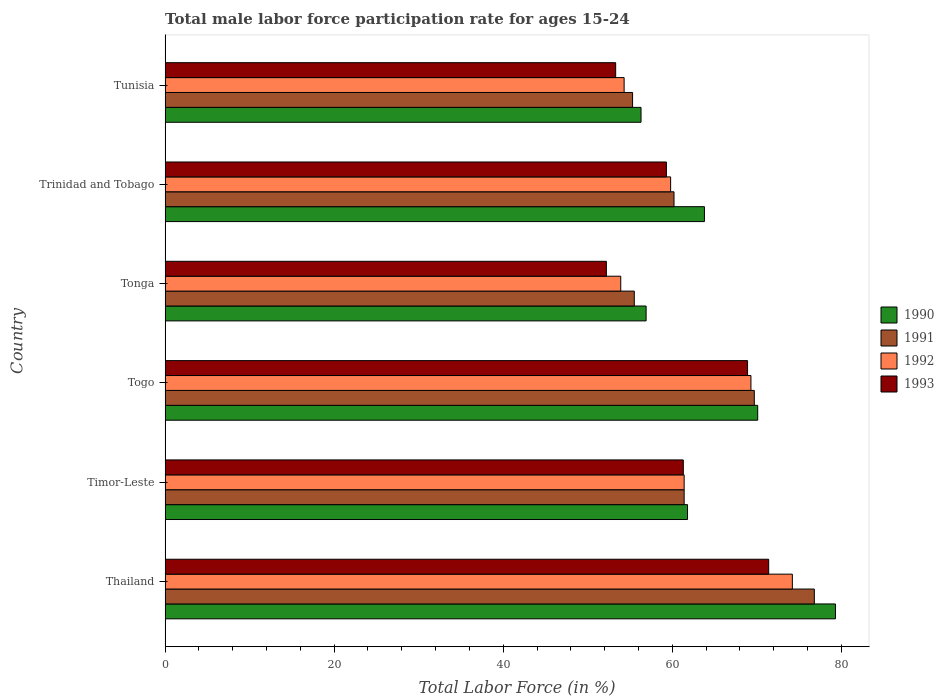Are the number of bars on each tick of the Y-axis equal?
Your answer should be compact. Yes. How many bars are there on the 1st tick from the bottom?
Your response must be concise. 4. What is the label of the 3rd group of bars from the top?
Keep it short and to the point. Tonga. In how many cases, is the number of bars for a given country not equal to the number of legend labels?
Make the answer very short. 0. What is the male labor force participation rate in 1993 in Trinidad and Tobago?
Your answer should be compact. 59.3. Across all countries, what is the maximum male labor force participation rate in 1993?
Your answer should be very brief. 71.4. Across all countries, what is the minimum male labor force participation rate in 1991?
Offer a terse response. 55.3. In which country was the male labor force participation rate in 1993 maximum?
Your answer should be compact. Thailand. In which country was the male labor force participation rate in 1991 minimum?
Offer a terse response. Tunisia. What is the total male labor force participation rate in 1992 in the graph?
Offer a terse response. 372.9. What is the difference between the male labor force participation rate in 1990 in Togo and that in Tonga?
Offer a very short reply. 13.2. What is the average male labor force participation rate in 1992 per country?
Offer a terse response. 62.15. In how many countries, is the male labor force participation rate in 1990 greater than 72 %?
Provide a short and direct response. 1. What is the ratio of the male labor force participation rate in 1991 in Thailand to that in Tonga?
Your response must be concise. 1.38. Is the male labor force participation rate in 1990 in Tonga less than that in Trinidad and Tobago?
Your answer should be compact. Yes. What is the difference between the highest and the second highest male labor force participation rate in 1991?
Provide a succinct answer. 7.1. What is the difference between the highest and the lowest male labor force participation rate in 1993?
Give a very brief answer. 19.2. In how many countries, is the male labor force participation rate in 1993 greater than the average male labor force participation rate in 1993 taken over all countries?
Provide a succinct answer. 3. Is it the case that in every country, the sum of the male labor force participation rate in 1991 and male labor force participation rate in 1990 is greater than the male labor force participation rate in 1992?
Give a very brief answer. Yes. Are all the bars in the graph horizontal?
Make the answer very short. Yes. How many countries are there in the graph?
Keep it short and to the point. 6. What is the difference between two consecutive major ticks on the X-axis?
Your answer should be compact. 20. Does the graph contain any zero values?
Your answer should be compact. No. Does the graph contain grids?
Keep it short and to the point. No. How many legend labels are there?
Your answer should be very brief. 4. What is the title of the graph?
Provide a succinct answer. Total male labor force participation rate for ages 15-24. What is the label or title of the X-axis?
Offer a terse response. Total Labor Force (in %). What is the label or title of the Y-axis?
Give a very brief answer. Country. What is the Total Labor Force (in %) of 1990 in Thailand?
Your answer should be very brief. 79.3. What is the Total Labor Force (in %) of 1991 in Thailand?
Offer a terse response. 76.8. What is the Total Labor Force (in %) of 1992 in Thailand?
Your answer should be very brief. 74.2. What is the Total Labor Force (in %) of 1993 in Thailand?
Offer a very short reply. 71.4. What is the Total Labor Force (in %) in 1990 in Timor-Leste?
Ensure brevity in your answer.  61.8. What is the Total Labor Force (in %) in 1991 in Timor-Leste?
Offer a very short reply. 61.4. What is the Total Labor Force (in %) in 1992 in Timor-Leste?
Your response must be concise. 61.4. What is the Total Labor Force (in %) in 1993 in Timor-Leste?
Keep it short and to the point. 61.3. What is the Total Labor Force (in %) of 1990 in Togo?
Keep it short and to the point. 70.1. What is the Total Labor Force (in %) in 1991 in Togo?
Offer a terse response. 69.7. What is the Total Labor Force (in %) of 1992 in Togo?
Keep it short and to the point. 69.3. What is the Total Labor Force (in %) of 1993 in Togo?
Make the answer very short. 68.9. What is the Total Labor Force (in %) of 1990 in Tonga?
Offer a terse response. 56.9. What is the Total Labor Force (in %) of 1991 in Tonga?
Provide a succinct answer. 55.5. What is the Total Labor Force (in %) of 1992 in Tonga?
Make the answer very short. 53.9. What is the Total Labor Force (in %) in 1993 in Tonga?
Provide a succinct answer. 52.2. What is the Total Labor Force (in %) of 1990 in Trinidad and Tobago?
Give a very brief answer. 63.8. What is the Total Labor Force (in %) of 1991 in Trinidad and Tobago?
Provide a succinct answer. 60.2. What is the Total Labor Force (in %) of 1992 in Trinidad and Tobago?
Your answer should be compact. 59.8. What is the Total Labor Force (in %) in 1993 in Trinidad and Tobago?
Keep it short and to the point. 59.3. What is the Total Labor Force (in %) in 1990 in Tunisia?
Offer a very short reply. 56.3. What is the Total Labor Force (in %) in 1991 in Tunisia?
Provide a succinct answer. 55.3. What is the Total Labor Force (in %) of 1992 in Tunisia?
Offer a terse response. 54.3. What is the Total Labor Force (in %) of 1993 in Tunisia?
Your answer should be very brief. 53.3. Across all countries, what is the maximum Total Labor Force (in %) of 1990?
Your response must be concise. 79.3. Across all countries, what is the maximum Total Labor Force (in %) of 1991?
Provide a short and direct response. 76.8. Across all countries, what is the maximum Total Labor Force (in %) in 1992?
Provide a succinct answer. 74.2. Across all countries, what is the maximum Total Labor Force (in %) of 1993?
Give a very brief answer. 71.4. Across all countries, what is the minimum Total Labor Force (in %) in 1990?
Ensure brevity in your answer.  56.3. Across all countries, what is the minimum Total Labor Force (in %) of 1991?
Make the answer very short. 55.3. Across all countries, what is the minimum Total Labor Force (in %) of 1992?
Your response must be concise. 53.9. Across all countries, what is the minimum Total Labor Force (in %) of 1993?
Provide a short and direct response. 52.2. What is the total Total Labor Force (in %) in 1990 in the graph?
Ensure brevity in your answer.  388.2. What is the total Total Labor Force (in %) of 1991 in the graph?
Keep it short and to the point. 378.9. What is the total Total Labor Force (in %) of 1992 in the graph?
Offer a terse response. 372.9. What is the total Total Labor Force (in %) of 1993 in the graph?
Your response must be concise. 366.4. What is the difference between the Total Labor Force (in %) in 1991 in Thailand and that in Timor-Leste?
Your answer should be very brief. 15.4. What is the difference between the Total Labor Force (in %) of 1990 in Thailand and that in Togo?
Your answer should be very brief. 9.2. What is the difference between the Total Labor Force (in %) in 1992 in Thailand and that in Togo?
Offer a terse response. 4.9. What is the difference between the Total Labor Force (in %) of 1990 in Thailand and that in Tonga?
Your answer should be compact. 22.4. What is the difference between the Total Labor Force (in %) in 1991 in Thailand and that in Tonga?
Your answer should be compact. 21.3. What is the difference between the Total Labor Force (in %) of 1992 in Thailand and that in Tonga?
Provide a succinct answer. 20.3. What is the difference between the Total Labor Force (in %) of 1993 in Thailand and that in Tonga?
Keep it short and to the point. 19.2. What is the difference between the Total Labor Force (in %) of 1990 in Thailand and that in Trinidad and Tobago?
Provide a short and direct response. 15.5. What is the difference between the Total Labor Force (in %) in 1992 in Thailand and that in Trinidad and Tobago?
Your answer should be compact. 14.4. What is the difference between the Total Labor Force (in %) of 1993 in Thailand and that in Trinidad and Tobago?
Give a very brief answer. 12.1. What is the difference between the Total Labor Force (in %) in 1991 in Thailand and that in Tunisia?
Your response must be concise. 21.5. What is the difference between the Total Labor Force (in %) of 1991 in Timor-Leste and that in Togo?
Your answer should be compact. -8.3. What is the difference between the Total Labor Force (in %) of 1992 in Timor-Leste and that in Togo?
Offer a very short reply. -7.9. What is the difference between the Total Labor Force (in %) of 1990 in Timor-Leste and that in Tonga?
Provide a succinct answer. 4.9. What is the difference between the Total Labor Force (in %) in 1991 in Timor-Leste and that in Tonga?
Give a very brief answer. 5.9. What is the difference between the Total Labor Force (in %) of 1992 in Timor-Leste and that in Tonga?
Make the answer very short. 7.5. What is the difference between the Total Labor Force (in %) of 1990 in Timor-Leste and that in Trinidad and Tobago?
Provide a short and direct response. -2. What is the difference between the Total Labor Force (in %) in 1991 in Timor-Leste and that in Trinidad and Tobago?
Provide a short and direct response. 1.2. What is the difference between the Total Labor Force (in %) of 1992 in Timor-Leste and that in Trinidad and Tobago?
Make the answer very short. 1.6. What is the difference between the Total Labor Force (in %) in 1993 in Timor-Leste and that in Tunisia?
Offer a terse response. 8. What is the difference between the Total Labor Force (in %) of 1990 in Togo and that in Tonga?
Ensure brevity in your answer.  13.2. What is the difference between the Total Labor Force (in %) in 1992 in Togo and that in Tonga?
Keep it short and to the point. 15.4. What is the difference between the Total Labor Force (in %) of 1993 in Togo and that in Tonga?
Provide a short and direct response. 16.7. What is the difference between the Total Labor Force (in %) of 1991 in Togo and that in Trinidad and Tobago?
Offer a terse response. 9.5. What is the difference between the Total Labor Force (in %) of 1993 in Togo and that in Trinidad and Tobago?
Give a very brief answer. 9.6. What is the difference between the Total Labor Force (in %) in 1990 in Togo and that in Tunisia?
Provide a short and direct response. 13.8. What is the difference between the Total Labor Force (in %) in 1992 in Togo and that in Tunisia?
Provide a succinct answer. 15. What is the difference between the Total Labor Force (in %) in 1993 in Togo and that in Tunisia?
Your answer should be very brief. 15.6. What is the difference between the Total Labor Force (in %) in 1990 in Tonga and that in Trinidad and Tobago?
Offer a very short reply. -6.9. What is the difference between the Total Labor Force (in %) of 1993 in Tonga and that in Trinidad and Tobago?
Provide a short and direct response. -7.1. What is the difference between the Total Labor Force (in %) in 1991 in Tonga and that in Tunisia?
Ensure brevity in your answer.  0.2. What is the difference between the Total Labor Force (in %) in 1993 in Tonga and that in Tunisia?
Give a very brief answer. -1.1. What is the difference between the Total Labor Force (in %) in 1991 in Trinidad and Tobago and that in Tunisia?
Give a very brief answer. 4.9. What is the difference between the Total Labor Force (in %) in 1992 in Trinidad and Tobago and that in Tunisia?
Provide a succinct answer. 5.5. What is the difference between the Total Labor Force (in %) in 1993 in Trinidad and Tobago and that in Tunisia?
Offer a very short reply. 6. What is the difference between the Total Labor Force (in %) of 1990 in Thailand and the Total Labor Force (in %) of 1991 in Timor-Leste?
Your answer should be compact. 17.9. What is the difference between the Total Labor Force (in %) of 1990 in Thailand and the Total Labor Force (in %) of 1992 in Timor-Leste?
Offer a terse response. 17.9. What is the difference between the Total Labor Force (in %) in 1990 in Thailand and the Total Labor Force (in %) in 1993 in Timor-Leste?
Give a very brief answer. 18. What is the difference between the Total Labor Force (in %) in 1991 in Thailand and the Total Labor Force (in %) in 1992 in Timor-Leste?
Provide a short and direct response. 15.4. What is the difference between the Total Labor Force (in %) of 1991 in Thailand and the Total Labor Force (in %) of 1993 in Timor-Leste?
Offer a very short reply. 15.5. What is the difference between the Total Labor Force (in %) in 1992 in Thailand and the Total Labor Force (in %) in 1993 in Timor-Leste?
Offer a very short reply. 12.9. What is the difference between the Total Labor Force (in %) of 1990 in Thailand and the Total Labor Force (in %) of 1991 in Togo?
Your answer should be compact. 9.6. What is the difference between the Total Labor Force (in %) of 1990 in Thailand and the Total Labor Force (in %) of 1993 in Togo?
Provide a succinct answer. 10.4. What is the difference between the Total Labor Force (in %) of 1990 in Thailand and the Total Labor Force (in %) of 1991 in Tonga?
Offer a terse response. 23.8. What is the difference between the Total Labor Force (in %) of 1990 in Thailand and the Total Labor Force (in %) of 1992 in Tonga?
Your answer should be compact. 25.4. What is the difference between the Total Labor Force (in %) in 1990 in Thailand and the Total Labor Force (in %) in 1993 in Tonga?
Your answer should be compact. 27.1. What is the difference between the Total Labor Force (in %) of 1991 in Thailand and the Total Labor Force (in %) of 1992 in Tonga?
Offer a very short reply. 22.9. What is the difference between the Total Labor Force (in %) in 1991 in Thailand and the Total Labor Force (in %) in 1993 in Tonga?
Your answer should be compact. 24.6. What is the difference between the Total Labor Force (in %) in 1992 in Thailand and the Total Labor Force (in %) in 1993 in Tonga?
Offer a very short reply. 22. What is the difference between the Total Labor Force (in %) of 1990 in Thailand and the Total Labor Force (in %) of 1993 in Trinidad and Tobago?
Offer a very short reply. 20. What is the difference between the Total Labor Force (in %) in 1991 in Thailand and the Total Labor Force (in %) in 1992 in Trinidad and Tobago?
Keep it short and to the point. 17. What is the difference between the Total Labor Force (in %) of 1991 in Thailand and the Total Labor Force (in %) of 1993 in Trinidad and Tobago?
Offer a terse response. 17.5. What is the difference between the Total Labor Force (in %) of 1990 in Thailand and the Total Labor Force (in %) of 1992 in Tunisia?
Provide a succinct answer. 25. What is the difference between the Total Labor Force (in %) in 1992 in Thailand and the Total Labor Force (in %) in 1993 in Tunisia?
Make the answer very short. 20.9. What is the difference between the Total Labor Force (in %) of 1990 in Timor-Leste and the Total Labor Force (in %) of 1991 in Togo?
Give a very brief answer. -7.9. What is the difference between the Total Labor Force (in %) of 1990 in Timor-Leste and the Total Labor Force (in %) of 1992 in Togo?
Offer a very short reply. -7.5. What is the difference between the Total Labor Force (in %) of 1990 in Timor-Leste and the Total Labor Force (in %) of 1993 in Togo?
Ensure brevity in your answer.  -7.1. What is the difference between the Total Labor Force (in %) in 1991 in Timor-Leste and the Total Labor Force (in %) in 1992 in Togo?
Provide a short and direct response. -7.9. What is the difference between the Total Labor Force (in %) in 1991 in Timor-Leste and the Total Labor Force (in %) in 1993 in Togo?
Offer a terse response. -7.5. What is the difference between the Total Labor Force (in %) of 1992 in Timor-Leste and the Total Labor Force (in %) of 1993 in Togo?
Your answer should be very brief. -7.5. What is the difference between the Total Labor Force (in %) of 1990 in Timor-Leste and the Total Labor Force (in %) of 1991 in Tonga?
Your answer should be very brief. 6.3. What is the difference between the Total Labor Force (in %) of 1990 in Timor-Leste and the Total Labor Force (in %) of 1993 in Tonga?
Ensure brevity in your answer.  9.6. What is the difference between the Total Labor Force (in %) of 1992 in Timor-Leste and the Total Labor Force (in %) of 1993 in Tonga?
Ensure brevity in your answer.  9.2. What is the difference between the Total Labor Force (in %) in 1990 in Timor-Leste and the Total Labor Force (in %) in 1991 in Trinidad and Tobago?
Give a very brief answer. 1.6. What is the difference between the Total Labor Force (in %) of 1990 in Timor-Leste and the Total Labor Force (in %) of 1993 in Trinidad and Tobago?
Provide a short and direct response. 2.5. What is the difference between the Total Labor Force (in %) in 1992 in Timor-Leste and the Total Labor Force (in %) in 1993 in Trinidad and Tobago?
Ensure brevity in your answer.  2.1. What is the difference between the Total Labor Force (in %) in 1991 in Timor-Leste and the Total Labor Force (in %) in 1992 in Tunisia?
Offer a terse response. 7.1. What is the difference between the Total Labor Force (in %) of 1992 in Timor-Leste and the Total Labor Force (in %) of 1993 in Tunisia?
Keep it short and to the point. 8.1. What is the difference between the Total Labor Force (in %) in 1990 in Togo and the Total Labor Force (in %) in 1991 in Tonga?
Ensure brevity in your answer.  14.6. What is the difference between the Total Labor Force (in %) of 1991 in Togo and the Total Labor Force (in %) of 1992 in Tonga?
Your answer should be compact. 15.8. What is the difference between the Total Labor Force (in %) in 1991 in Togo and the Total Labor Force (in %) in 1993 in Tonga?
Keep it short and to the point. 17.5. What is the difference between the Total Labor Force (in %) of 1990 in Togo and the Total Labor Force (in %) of 1991 in Trinidad and Tobago?
Your answer should be compact. 9.9. What is the difference between the Total Labor Force (in %) in 1990 in Togo and the Total Labor Force (in %) in 1993 in Trinidad and Tobago?
Make the answer very short. 10.8. What is the difference between the Total Labor Force (in %) of 1991 in Togo and the Total Labor Force (in %) of 1993 in Trinidad and Tobago?
Offer a terse response. 10.4. What is the difference between the Total Labor Force (in %) of 1992 in Togo and the Total Labor Force (in %) of 1993 in Trinidad and Tobago?
Ensure brevity in your answer.  10. What is the difference between the Total Labor Force (in %) of 1990 in Togo and the Total Labor Force (in %) of 1993 in Tunisia?
Ensure brevity in your answer.  16.8. What is the difference between the Total Labor Force (in %) in 1991 in Togo and the Total Labor Force (in %) in 1992 in Tunisia?
Provide a succinct answer. 15.4. What is the difference between the Total Labor Force (in %) in 1991 in Togo and the Total Labor Force (in %) in 1993 in Tunisia?
Provide a succinct answer. 16.4. What is the difference between the Total Labor Force (in %) in 1992 in Togo and the Total Labor Force (in %) in 1993 in Tunisia?
Offer a very short reply. 16. What is the difference between the Total Labor Force (in %) of 1990 in Tonga and the Total Labor Force (in %) of 1991 in Trinidad and Tobago?
Your answer should be compact. -3.3. What is the difference between the Total Labor Force (in %) in 1990 in Tonga and the Total Labor Force (in %) in 1992 in Trinidad and Tobago?
Your answer should be very brief. -2.9. What is the difference between the Total Labor Force (in %) in 1990 in Tonga and the Total Labor Force (in %) in 1993 in Trinidad and Tobago?
Your response must be concise. -2.4. What is the difference between the Total Labor Force (in %) in 1991 in Tonga and the Total Labor Force (in %) in 1993 in Trinidad and Tobago?
Offer a very short reply. -3.8. What is the difference between the Total Labor Force (in %) in 1990 in Tonga and the Total Labor Force (in %) in 1992 in Tunisia?
Provide a short and direct response. 2.6. What is the difference between the Total Labor Force (in %) in 1990 in Tonga and the Total Labor Force (in %) in 1993 in Tunisia?
Give a very brief answer. 3.6. What is the difference between the Total Labor Force (in %) of 1992 in Tonga and the Total Labor Force (in %) of 1993 in Tunisia?
Your answer should be very brief. 0.6. What is the difference between the Total Labor Force (in %) of 1990 in Trinidad and Tobago and the Total Labor Force (in %) of 1991 in Tunisia?
Offer a very short reply. 8.5. What is the difference between the Total Labor Force (in %) of 1990 in Trinidad and Tobago and the Total Labor Force (in %) of 1992 in Tunisia?
Your response must be concise. 9.5. What is the difference between the Total Labor Force (in %) in 1990 in Trinidad and Tobago and the Total Labor Force (in %) in 1993 in Tunisia?
Give a very brief answer. 10.5. What is the difference between the Total Labor Force (in %) of 1991 in Trinidad and Tobago and the Total Labor Force (in %) of 1992 in Tunisia?
Ensure brevity in your answer.  5.9. What is the difference between the Total Labor Force (in %) of 1991 in Trinidad and Tobago and the Total Labor Force (in %) of 1993 in Tunisia?
Offer a terse response. 6.9. What is the average Total Labor Force (in %) of 1990 per country?
Make the answer very short. 64.7. What is the average Total Labor Force (in %) of 1991 per country?
Provide a short and direct response. 63.15. What is the average Total Labor Force (in %) in 1992 per country?
Give a very brief answer. 62.15. What is the average Total Labor Force (in %) of 1993 per country?
Make the answer very short. 61.07. What is the difference between the Total Labor Force (in %) of 1990 and Total Labor Force (in %) of 1991 in Thailand?
Keep it short and to the point. 2.5. What is the difference between the Total Labor Force (in %) of 1990 and Total Labor Force (in %) of 1992 in Thailand?
Your answer should be very brief. 5.1. What is the difference between the Total Labor Force (in %) in 1990 and Total Labor Force (in %) in 1993 in Thailand?
Make the answer very short. 7.9. What is the difference between the Total Labor Force (in %) in 1992 and Total Labor Force (in %) in 1993 in Thailand?
Ensure brevity in your answer.  2.8. What is the difference between the Total Labor Force (in %) in 1990 and Total Labor Force (in %) in 1991 in Timor-Leste?
Ensure brevity in your answer.  0.4. What is the difference between the Total Labor Force (in %) of 1990 and Total Labor Force (in %) of 1993 in Timor-Leste?
Keep it short and to the point. 0.5. What is the difference between the Total Labor Force (in %) in 1991 and Total Labor Force (in %) in 1993 in Timor-Leste?
Your answer should be very brief. 0.1. What is the difference between the Total Labor Force (in %) in 1992 and Total Labor Force (in %) in 1993 in Timor-Leste?
Your answer should be very brief. 0.1. What is the difference between the Total Labor Force (in %) in 1990 and Total Labor Force (in %) in 1991 in Togo?
Keep it short and to the point. 0.4. What is the difference between the Total Labor Force (in %) of 1990 and Total Labor Force (in %) of 1993 in Togo?
Give a very brief answer. 1.2. What is the difference between the Total Labor Force (in %) of 1991 and Total Labor Force (in %) of 1992 in Togo?
Your response must be concise. 0.4. What is the difference between the Total Labor Force (in %) of 1990 and Total Labor Force (in %) of 1991 in Tonga?
Make the answer very short. 1.4. What is the difference between the Total Labor Force (in %) in 1990 and Total Labor Force (in %) in 1992 in Tonga?
Ensure brevity in your answer.  3. What is the difference between the Total Labor Force (in %) in 1990 and Total Labor Force (in %) in 1993 in Tonga?
Keep it short and to the point. 4.7. What is the difference between the Total Labor Force (in %) in 1991 and Total Labor Force (in %) in 1992 in Tonga?
Give a very brief answer. 1.6. What is the difference between the Total Labor Force (in %) of 1991 and Total Labor Force (in %) of 1993 in Tonga?
Your response must be concise. 3.3. What is the difference between the Total Labor Force (in %) of 1990 and Total Labor Force (in %) of 1992 in Trinidad and Tobago?
Ensure brevity in your answer.  4. What is the ratio of the Total Labor Force (in %) of 1990 in Thailand to that in Timor-Leste?
Your answer should be very brief. 1.28. What is the ratio of the Total Labor Force (in %) in 1991 in Thailand to that in Timor-Leste?
Your answer should be compact. 1.25. What is the ratio of the Total Labor Force (in %) in 1992 in Thailand to that in Timor-Leste?
Your answer should be very brief. 1.21. What is the ratio of the Total Labor Force (in %) in 1993 in Thailand to that in Timor-Leste?
Your answer should be compact. 1.16. What is the ratio of the Total Labor Force (in %) in 1990 in Thailand to that in Togo?
Ensure brevity in your answer.  1.13. What is the ratio of the Total Labor Force (in %) in 1991 in Thailand to that in Togo?
Provide a succinct answer. 1.1. What is the ratio of the Total Labor Force (in %) in 1992 in Thailand to that in Togo?
Provide a succinct answer. 1.07. What is the ratio of the Total Labor Force (in %) of 1993 in Thailand to that in Togo?
Offer a terse response. 1.04. What is the ratio of the Total Labor Force (in %) in 1990 in Thailand to that in Tonga?
Offer a terse response. 1.39. What is the ratio of the Total Labor Force (in %) of 1991 in Thailand to that in Tonga?
Offer a very short reply. 1.38. What is the ratio of the Total Labor Force (in %) in 1992 in Thailand to that in Tonga?
Ensure brevity in your answer.  1.38. What is the ratio of the Total Labor Force (in %) of 1993 in Thailand to that in Tonga?
Offer a very short reply. 1.37. What is the ratio of the Total Labor Force (in %) of 1990 in Thailand to that in Trinidad and Tobago?
Your answer should be compact. 1.24. What is the ratio of the Total Labor Force (in %) in 1991 in Thailand to that in Trinidad and Tobago?
Offer a very short reply. 1.28. What is the ratio of the Total Labor Force (in %) in 1992 in Thailand to that in Trinidad and Tobago?
Your answer should be very brief. 1.24. What is the ratio of the Total Labor Force (in %) of 1993 in Thailand to that in Trinidad and Tobago?
Give a very brief answer. 1.2. What is the ratio of the Total Labor Force (in %) of 1990 in Thailand to that in Tunisia?
Your answer should be very brief. 1.41. What is the ratio of the Total Labor Force (in %) in 1991 in Thailand to that in Tunisia?
Give a very brief answer. 1.39. What is the ratio of the Total Labor Force (in %) in 1992 in Thailand to that in Tunisia?
Provide a succinct answer. 1.37. What is the ratio of the Total Labor Force (in %) in 1993 in Thailand to that in Tunisia?
Make the answer very short. 1.34. What is the ratio of the Total Labor Force (in %) of 1990 in Timor-Leste to that in Togo?
Your response must be concise. 0.88. What is the ratio of the Total Labor Force (in %) in 1991 in Timor-Leste to that in Togo?
Give a very brief answer. 0.88. What is the ratio of the Total Labor Force (in %) of 1992 in Timor-Leste to that in Togo?
Ensure brevity in your answer.  0.89. What is the ratio of the Total Labor Force (in %) in 1993 in Timor-Leste to that in Togo?
Keep it short and to the point. 0.89. What is the ratio of the Total Labor Force (in %) of 1990 in Timor-Leste to that in Tonga?
Provide a short and direct response. 1.09. What is the ratio of the Total Labor Force (in %) of 1991 in Timor-Leste to that in Tonga?
Your response must be concise. 1.11. What is the ratio of the Total Labor Force (in %) in 1992 in Timor-Leste to that in Tonga?
Provide a short and direct response. 1.14. What is the ratio of the Total Labor Force (in %) of 1993 in Timor-Leste to that in Tonga?
Give a very brief answer. 1.17. What is the ratio of the Total Labor Force (in %) in 1990 in Timor-Leste to that in Trinidad and Tobago?
Provide a short and direct response. 0.97. What is the ratio of the Total Labor Force (in %) of 1991 in Timor-Leste to that in Trinidad and Tobago?
Your answer should be compact. 1.02. What is the ratio of the Total Labor Force (in %) of 1992 in Timor-Leste to that in Trinidad and Tobago?
Provide a succinct answer. 1.03. What is the ratio of the Total Labor Force (in %) in 1993 in Timor-Leste to that in Trinidad and Tobago?
Keep it short and to the point. 1.03. What is the ratio of the Total Labor Force (in %) of 1990 in Timor-Leste to that in Tunisia?
Offer a very short reply. 1.1. What is the ratio of the Total Labor Force (in %) of 1991 in Timor-Leste to that in Tunisia?
Ensure brevity in your answer.  1.11. What is the ratio of the Total Labor Force (in %) of 1992 in Timor-Leste to that in Tunisia?
Give a very brief answer. 1.13. What is the ratio of the Total Labor Force (in %) in 1993 in Timor-Leste to that in Tunisia?
Keep it short and to the point. 1.15. What is the ratio of the Total Labor Force (in %) in 1990 in Togo to that in Tonga?
Offer a terse response. 1.23. What is the ratio of the Total Labor Force (in %) of 1991 in Togo to that in Tonga?
Offer a very short reply. 1.26. What is the ratio of the Total Labor Force (in %) of 1992 in Togo to that in Tonga?
Your answer should be compact. 1.29. What is the ratio of the Total Labor Force (in %) of 1993 in Togo to that in Tonga?
Make the answer very short. 1.32. What is the ratio of the Total Labor Force (in %) of 1990 in Togo to that in Trinidad and Tobago?
Provide a succinct answer. 1.1. What is the ratio of the Total Labor Force (in %) of 1991 in Togo to that in Trinidad and Tobago?
Offer a very short reply. 1.16. What is the ratio of the Total Labor Force (in %) of 1992 in Togo to that in Trinidad and Tobago?
Keep it short and to the point. 1.16. What is the ratio of the Total Labor Force (in %) in 1993 in Togo to that in Trinidad and Tobago?
Make the answer very short. 1.16. What is the ratio of the Total Labor Force (in %) in 1990 in Togo to that in Tunisia?
Ensure brevity in your answer.  1.25. What is the ratio of the Total Labor Force (in %) of 1991 in Togo to that in Tunisia?
Ensure brevity in your answer.  1.26. What is the ratio of the Total Labor Force (in %) of 1992 in Togo to that in Tunisia?
Keep it short and to the point. 1.28. What is the ratio of the Total Labor Force (in %) of 1993 in Togo to that in Tunisia?
Offer a terse response. 1.29. What is the ratio of the Total Labor Force (in %) of 1990 in Tonga to that in Trinidad and Tobago?
Offer a very short reply. 0.89. What is the ratio of the Total Labor Force (in %) in 1991 in Tonga to that in Trinidad and Tobago?
Give a very brief answer. 0.92. What is the ratio of the Total Labor Force (in %) of 1992 in Tonga to that in Trinidad and Tobago?
Give a very brief answer. 0.9. What is the ratio of the Total Labor Force (in %) in 1993 in Tonga to that in Trinidad and Tobago?
Provide a succinct answer. 0.88. What is the ratio of the Total Labor Force (in %) in 1990 in Tonga to that in Tunisia?
Ensure brevity in your answer.  1.01. What is the ratio of the Total Labor Force (in %) of 1991 in Tonga to that in Tunisia?
Give a very brief answer. 1. What is the ratio of the Total Labor Force (in %) in 1993 in Tonga to that in Tunisia?
Your response must be concise. 0.98. What is the ratio of the Total Labor Force (in %) of 1990 in Trinidad and Tobago to that in Tunisia?
Keep it short and to the point. 1.13. What is the ratio of the Total Labor Force (in %) of 1991 in Trinidad and Tobago to that in Tunisia?
Your response must be concise. 1.09. What is the ratio of the Total Labor Force (in %) of 1992 in Trinidad and Tobago to that in Tunisia?
Ensure brevity in your answer.  1.1. What is the ratio of the Total Labor Force (in %) in 1993 in Trinidad and Tobago to that in Tunisia?
Offer a very short reply. 1.11. What is the difference between the highest and the second highest Total Labor Force (in %) of 1992?
Ensure brevity in your answer.  4.9. What is the difference between the highest and the lowest Total Labor Force (in %) of 1992?
Ensure brevity in your answer.  20.3. 